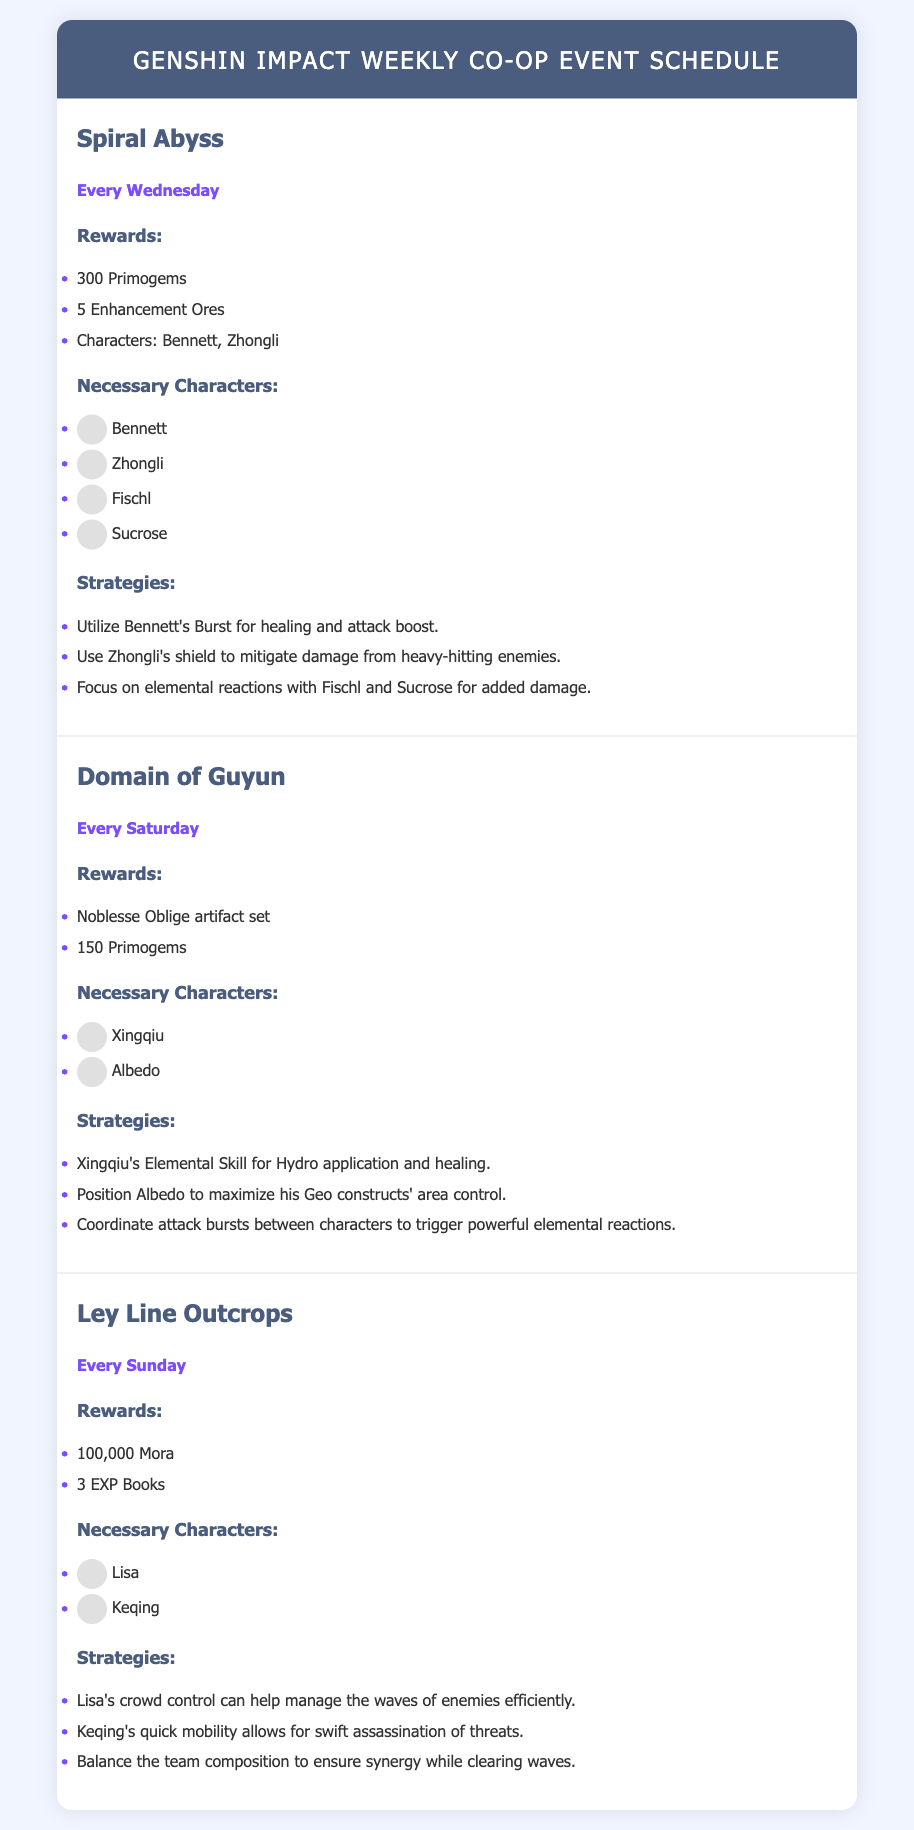What day does the Spiral Abyss event take place? The schedule indicates that the Spiral Abyss event occurs "Every Wednesday."
Answer: Wednesday What rewards do you receive from the Domain of Guyun event? The rewards listed under Domain of Guyun include "Noblesse Oblige artifact set" and "150 Primogems."
Answer: Noblesse Oblige artifact set, 150 Primogems Which characters are necessary for the Ley Line Outcrops event? The characters required for this event are listed as "Lisa" and "Keqing."
Answer: Lisa, Keqing What is a strategy for the Spiral Abyss? One strategy mentioned for the Spiral Abyss is utilizing "Bennett's Burst for healing and attack boost."
Answer: Bennett's Burst for healing and attack boost How many enhancement ores are awarded in the Spiral Abyss? The document specifies that the rewards include "5 Enhancement Ores."
Answer: 5 Enhancement Ores Which character should be positioned to maximize Geo constructs in the Domain of Guyun? The strategy states that "Position Albedo to maximize his Geo constructs' area control."
Answer: Albedo 